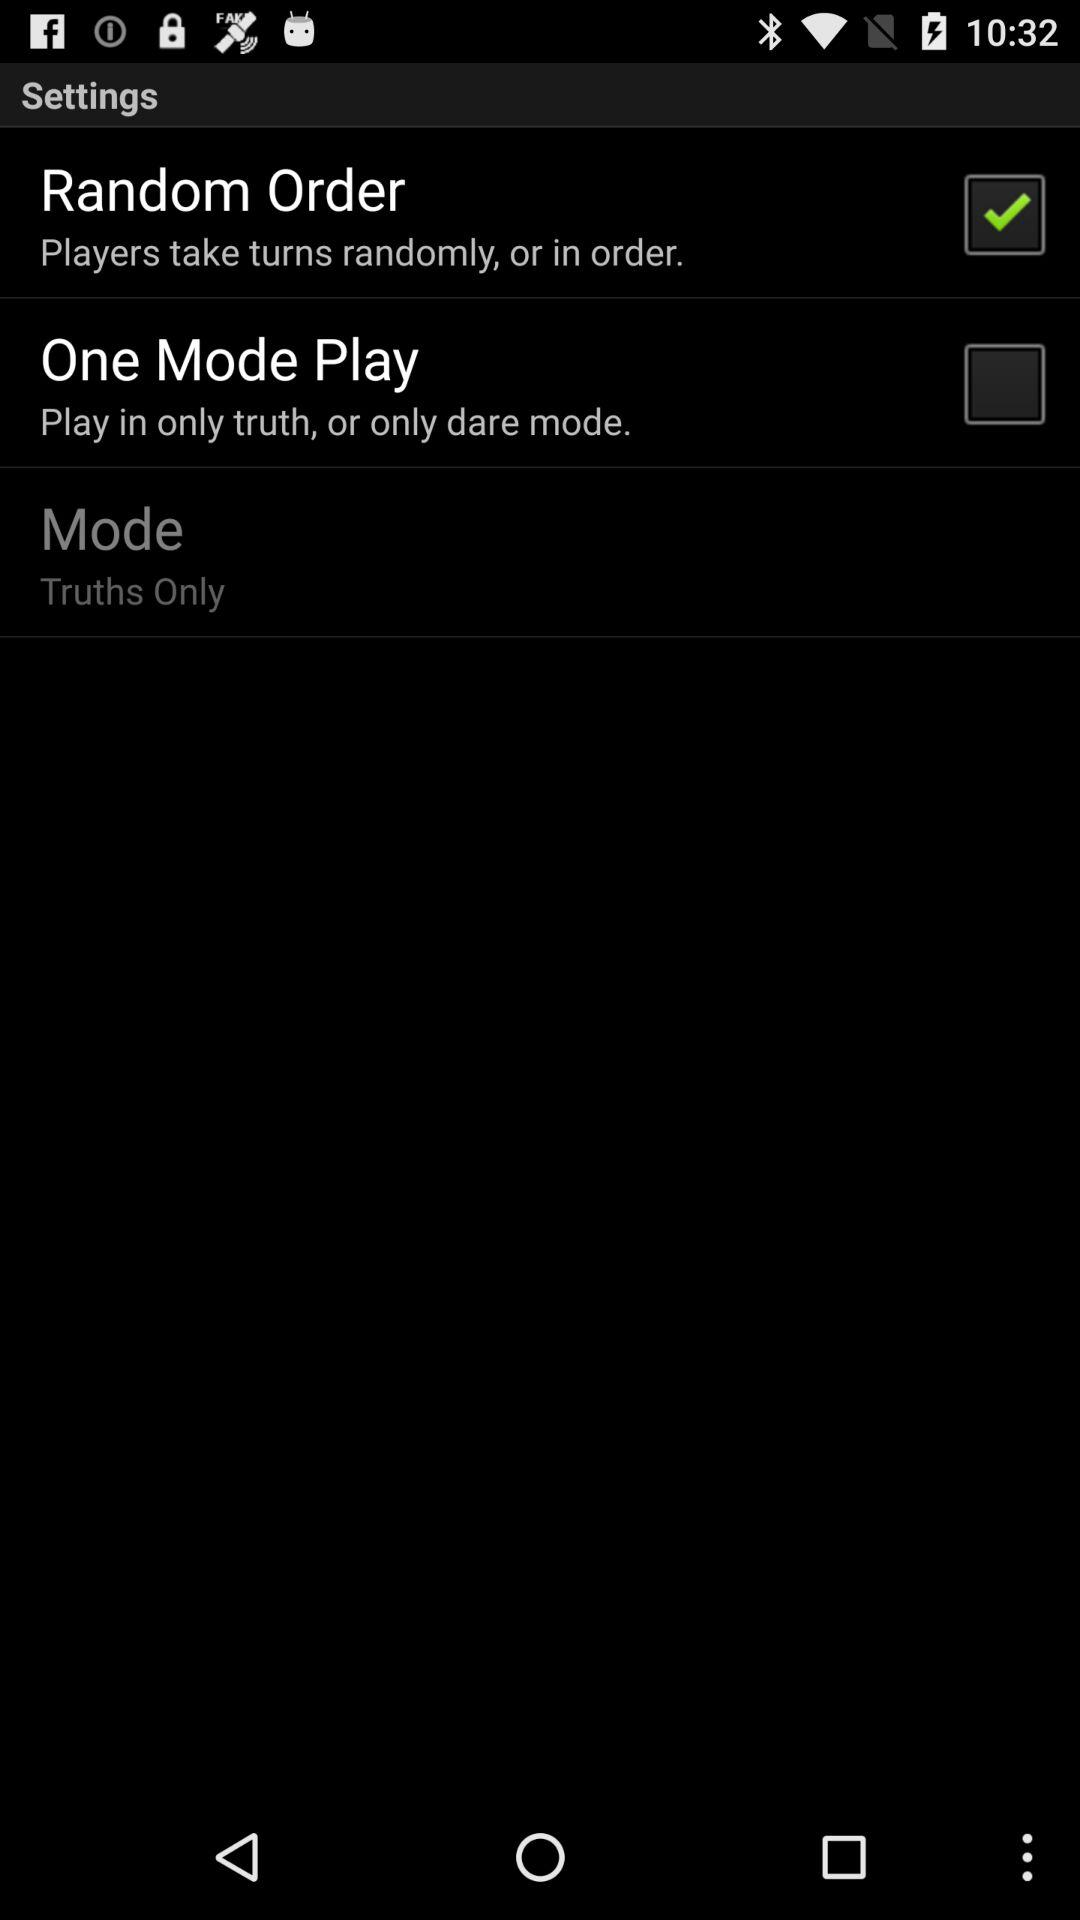How many checkboxes are on the screen?
Answer the question using a single word or phrase. 2 